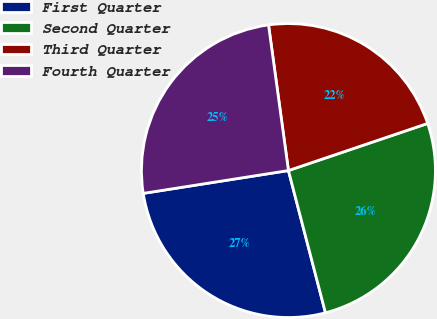<chart> <loc_0><loc_0><loc_500><loc_500><pie_chart><fcel>First Quarter<fcel>Second Quarter<fcel>Third Quarter<fcel>Fourth Quarter<nl><fcel>26.57%<fcel>26.14%<fcel>21.97%<fcel>25.32%<nl></chart> 